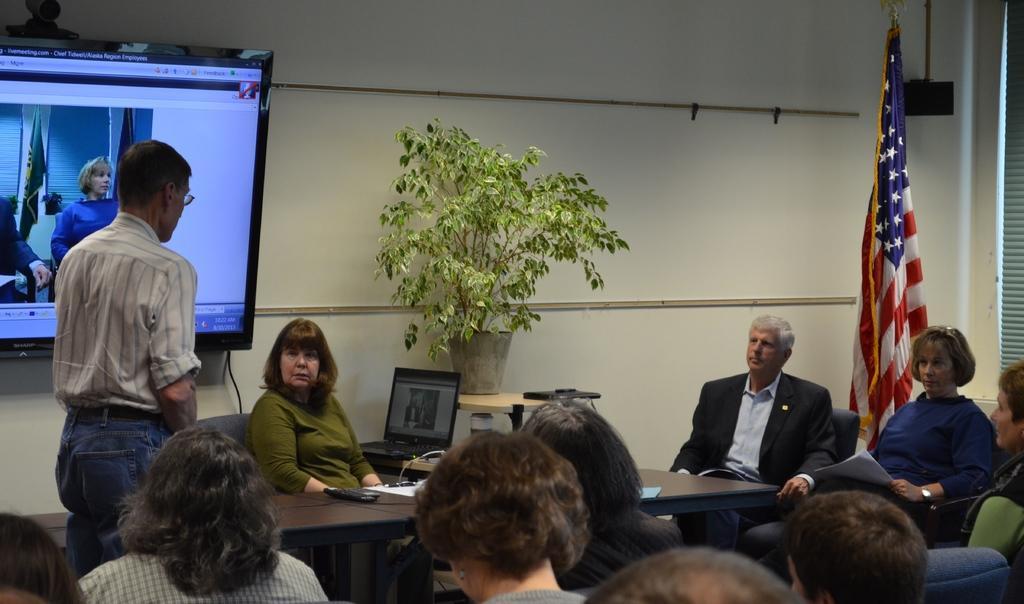Can you describe this image briefly? Persons are sitting on a chair. This person is standing. On this table there is a remote and papers. On this tablet there is a laptop and plant. Backside of this person's there is a american flag. A television on wall. This woman is holding papers. 